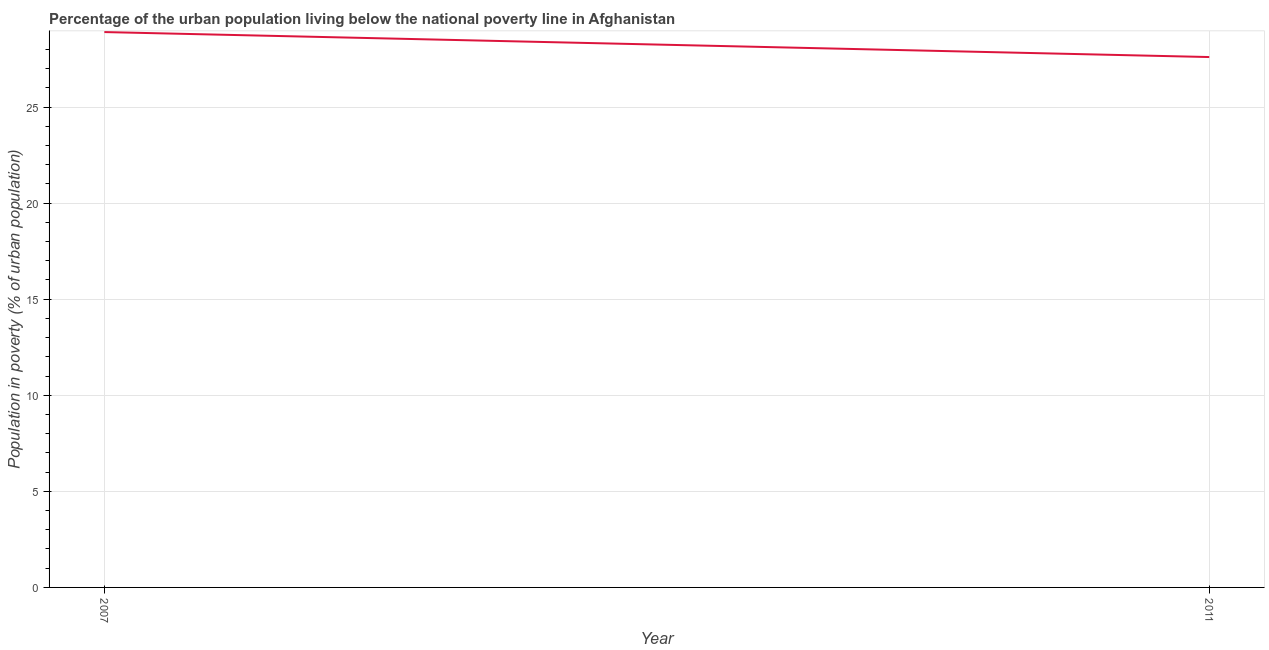What is the percentage of urban population living below poverty line in 2007?
Offer a very short reply. 28.9. Across all years, what is the maximum percentage of urban population living below poverty line?
Offer a terse response. 28.9. Across all years, what is the minimum percentage of urban population living below poverty line?
Ensure brevity in your answer.  27.6. In which year was the percentage of urban population living below poverty line maximum?
Your response must be concise. 2007. In which year was the percentage of urban population living below poverty line minimum?
Provide a succinct answer. 2011. What is the sum of the percentage of urban population living below poverty line?
Offer a very short reply. 56.5. What is the difference between the percentage of urban population living below poverty line in 2007 and 2011?
Ensure brevity in your answer.  1.3. What is the average percentage of urban population living below poverty line per year?
Offer a very short reply. 28.25. What is the median percentage of urban population living below poverty line?
Your answer should be compact. 28.25. Do a majority of the years between 2011 and 2007 (inclusive) have percentage of urban population living below poverty line greater than 12 %?
Provide a short and direct response. No. What is the ratio of the percentage of urban population living below poverty line in 2007 to that in 2011?
Make the answer very short. 1.05. Is the percentage of urban population living below poverty line in 2007 less than that in 2011?
Your answer should be very brief. No. In how many years, is the percentage of urban population living below poverty line greater than the average percentage of urban population living below poverty line taken over all years?
Your answer should be very brief. 1. Does the percentage of urban population living below poverty line monotonically increase over the years?
Ensure brevity in your answer.  No. Are the values on the major ticks of Y-axis written in scientific E-notation?
Provide a short and direct response. No. Does the graph contain any zero values?
Ensure brevity in your answer.  No. What is the title of the graph?
Your answer should be compact. Percentage of the urban population living below the national poverty line in Afghanistan. What is the label or title of the X-axis?
Keep it short and to the point. Year. What is the label or title of the Y-axis?
Ensure brevity in your answer.  Population in poverty (% of urban population). What is the Population in poverty (% of urban population) of 2007?
Give a very brief answer. 28.9. What is the Population in poverty (% of urban population) of 2011?
Offer a very short reply. 27.6. What is the ratio of the Population in poverty (% of urban population) in 2007 to that in 2011?
Give a very brief answer. 1.05. 